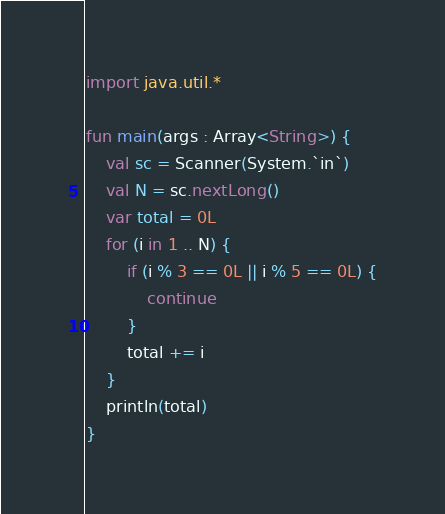Convert code to text. <code><loc_0><loc_0><loc_500><loc_500><_Kotlin_>import java.util.*

fun main(args : Array<String>) {
    val sc = Scanner(System.`in`)
    val N = sc.nextLong()
    var total = 0L
    for (i in 1 .. N) {
        if (i % 3 == 0L || i % 5 == 0L) {
            continue
        }
        total += i
    }
    println(total)
}
</code> 